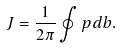Convert formula to latex. <formula><loc_0><loc_0><loc_500><loc_500>J = \frac { 1 } { 2 \pi } \oint p d b .</formula> 